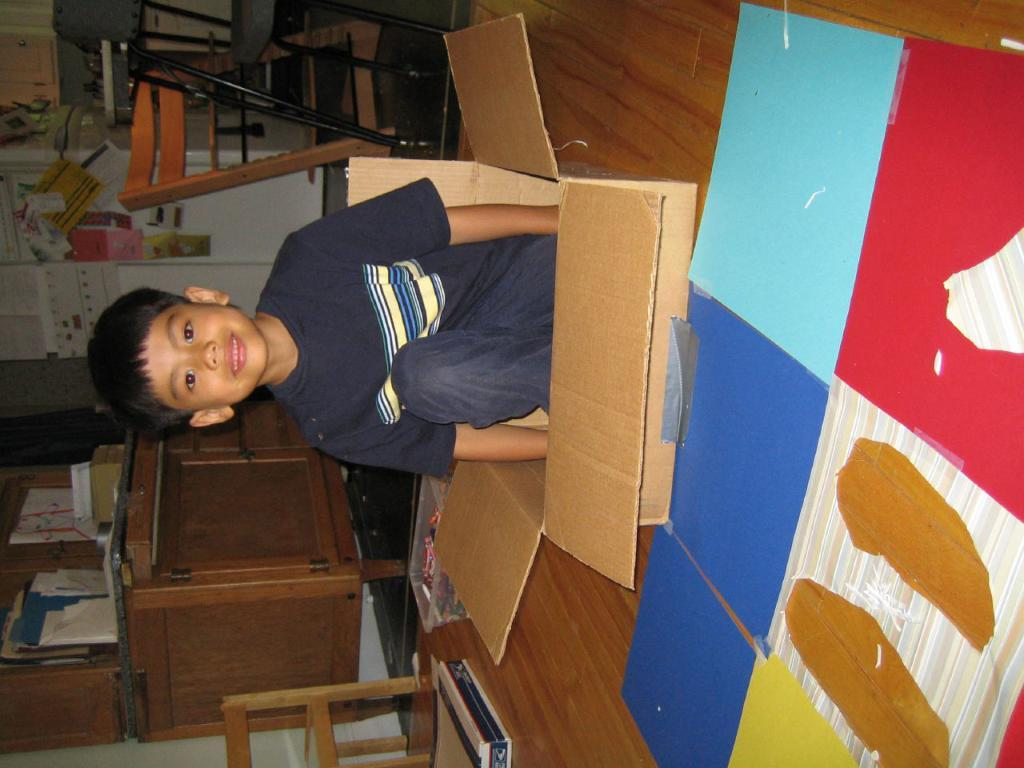Who is the main subject in the image? There is a boy in the image. What is the boy doing in the image? The boy is sitting in a box. What verse is the boy reciting in the image? There is no verse or recitation mentioned in the image; the boy is simply sitting in a box. 